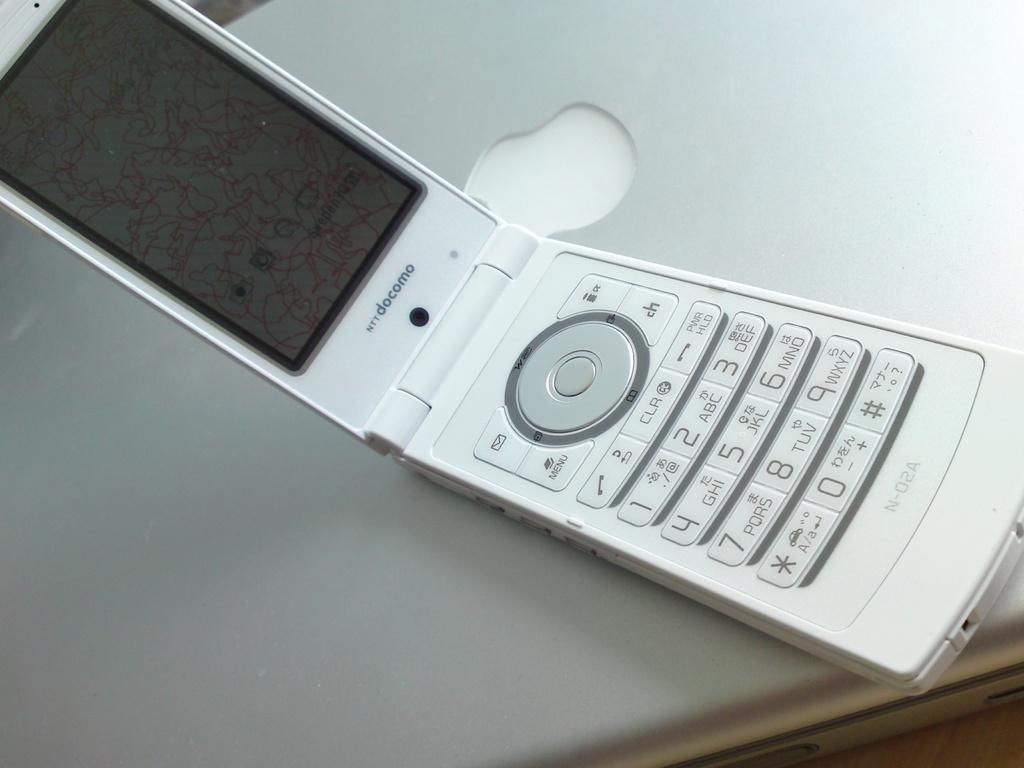What brand of phone?
Your answer should be compact. Docomo. Is this a smart phone?
Provide a succinct answer. No. 